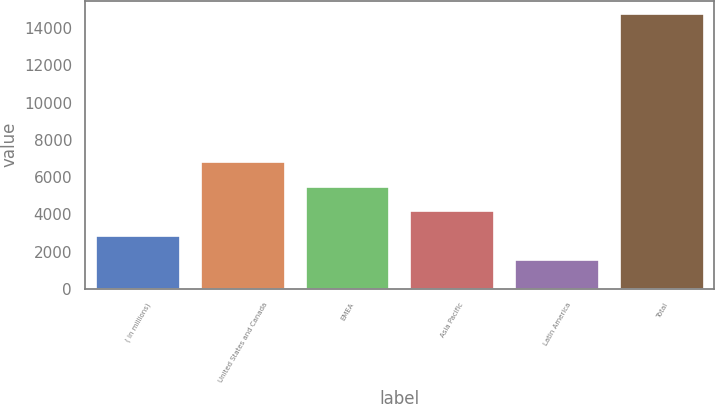Convert chart to OTSL. <chart><loc_0><loc_0><loc_500><loc_500><bar_chart><fcel>( in millions)<fcel>United States and Canada<fcel>EMEA<fcel>Asia Pacific<fcel>Latin America<fcel>Total<nl><fcel>2850.9<fcel>6816.6<fcel>5494.7<fcel>4172.8<fcel>1529<fcel>14748<nl></chart> 